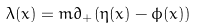Convert formula to latex. <formula><loc_0><loc_0><loc_500><loc_500>\lambda ( x ) = m \partial _ { + } ( \eta ( x ) - \phi ( x ) )</formula> 